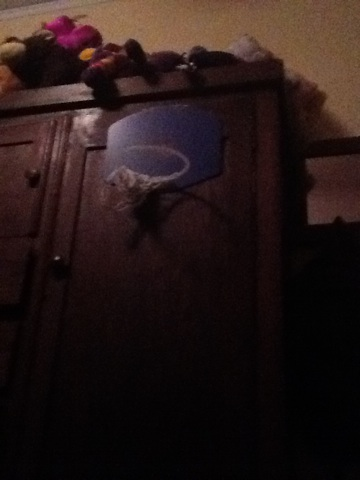Could this homemade hoop affect playing experience? Certainly, the homemade basketball hoop, due to its unconventional design and material, could offer a different playing experience. It may not have the same bounce or stability as a standard hoop, which could affect how the ball rebounds and the overall enjoyment of the game. It's great for casual play, but might not suffice for more rigorous practice. 